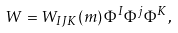Convert formula to latex. <formula><loc_0><loc_0><loc_500><loc_500>W = W _ { I J K } ( m ) \, \Phi ^ { I } \Phi ^ { j } \Phi ^ { K } ,</formula> 